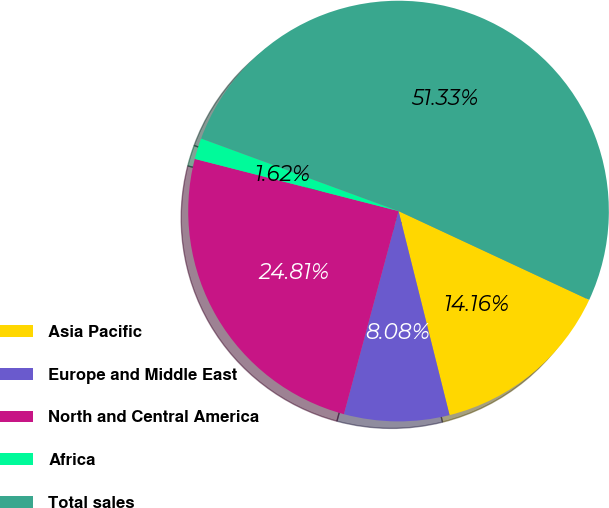Convert chart to OTSL. <chart><loc_0><loc_0><loc_500><loc_500><pie_chart><fcel>Asia Pacific<fcel>Europe and Middle East<fcel>North and Central America<fcel>Africa<fcel>Total sales<nl><fcel>14.16%<fcel>8.08%<fcel>24.81%<fcel>1.62%<fcel>51.33%<nl></chart> 